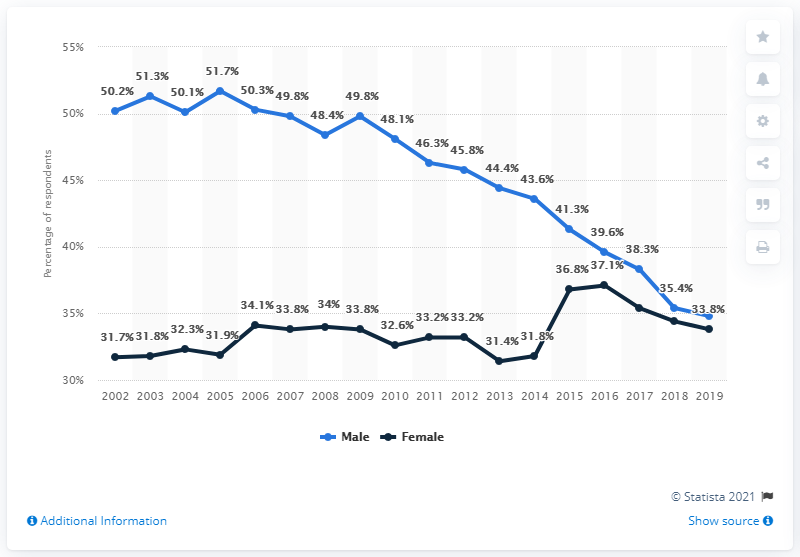Outline some significant characteristics in this image. The navy blue color indicates femininity. The year with the smallest gap between male and female in 2019 was. 